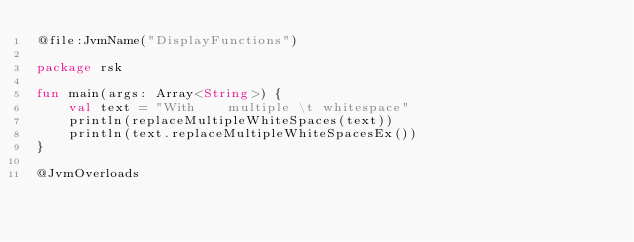<code> <loc_0><loc_0><loc_500><loc_500><_Kotlin_>@file:JvmName("DisplayFunctions")

package rsk

fun main(args: Array<String>) {
    val text = "With    multiple \t whitespace"
    println(replaceMultipleWhiteSpaces(text))
    println(text.replaceMultipleWhiteSpacesEx())
}

@JvmOverloads</code> 